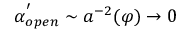Convert formula to latex. <formula><loc_0><loc_0><loc_500><loc_500>\alpha _ { o p e n } ^ { ^ { \prime } } \sim a ^ { - 2 } ( \varphi ) \rightarrow 0</formula> 